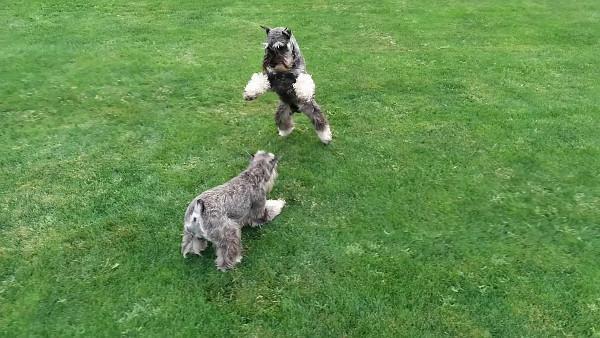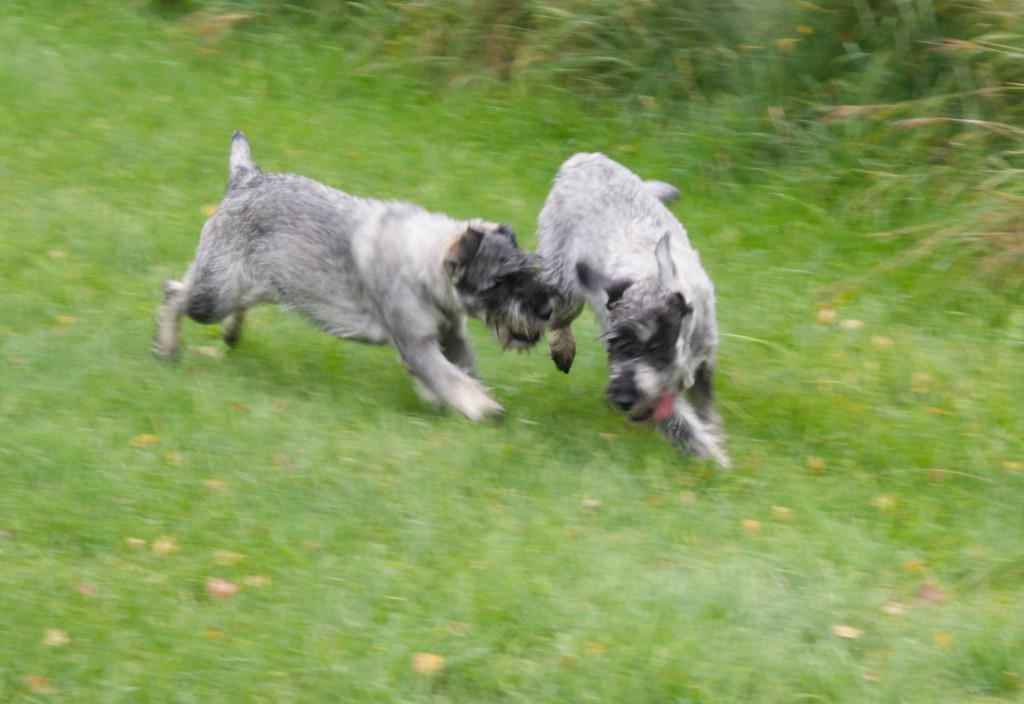The first image is the image on the left, the second image is the image on the right. For the images shown, is this caption "Two dogs are playing in the grass in at least one of the images." true? Answer yes or no. Yes. The first image is the image on the left, the second image is the image on the right. For the images shown, is this caption "A ball is in the grass in front of a dog in one image." true? Answer yes or no. No. 